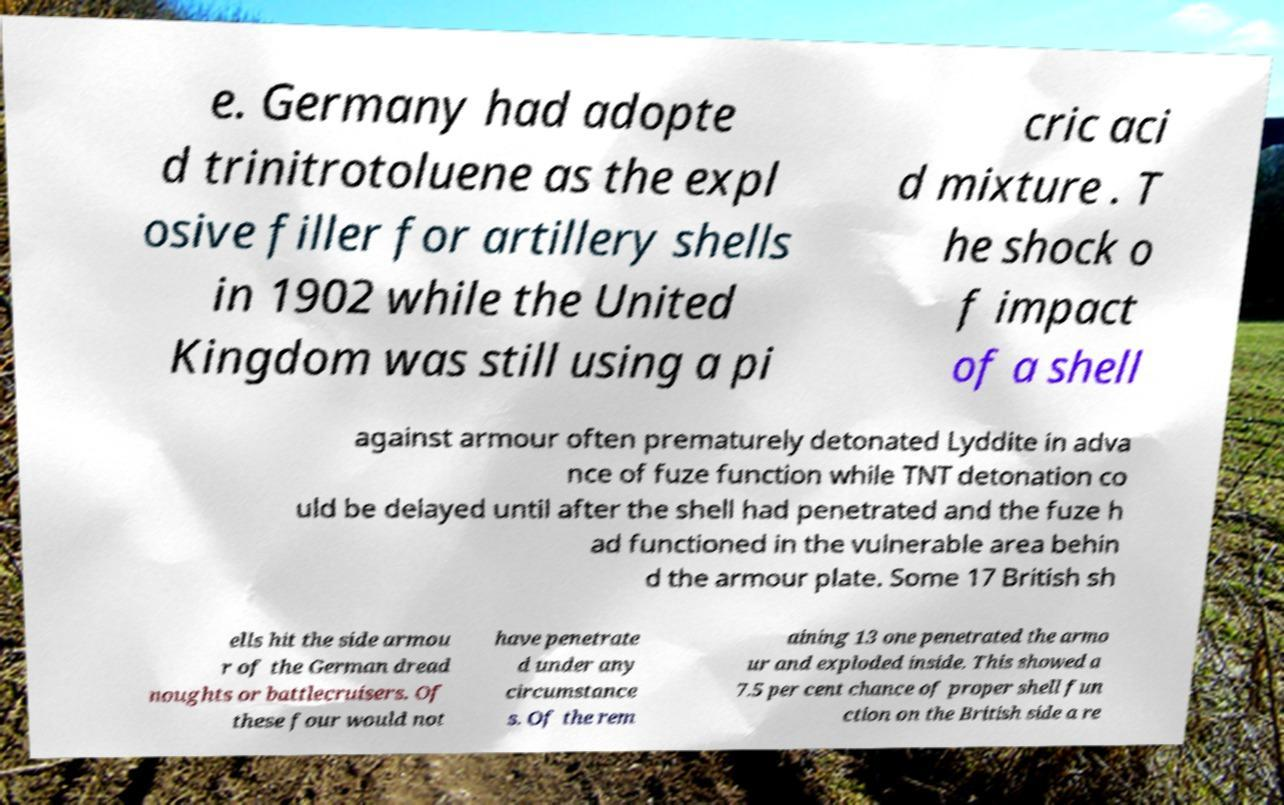What messages or text are displayed in this image? I need them in a readable, typed format. e. Germany had adopte d trinitrotoluene as the expl osive filler for artillery shells in 1902 while the United Kingdom was still using a pi cric aci d mixture . T he shock o f impact of a shell against armour often prematurely detonated Lyddite in adva nce of fuze function while TNT detonation co uld be delayed until after the shell had penetrated and the fuze h ad functioned in the vulnerable area behin d the armour plate. Some 17 British sh ells hit the side armou r of the German dread noughts or battlecruisers. Of these four would not have penetrate d under any circumstance s. Of the rem aining 13 one penetrated the armo ur and exploded inside. This showed a 7.5 per cent chance of proper shell fun ction on the British side a re 